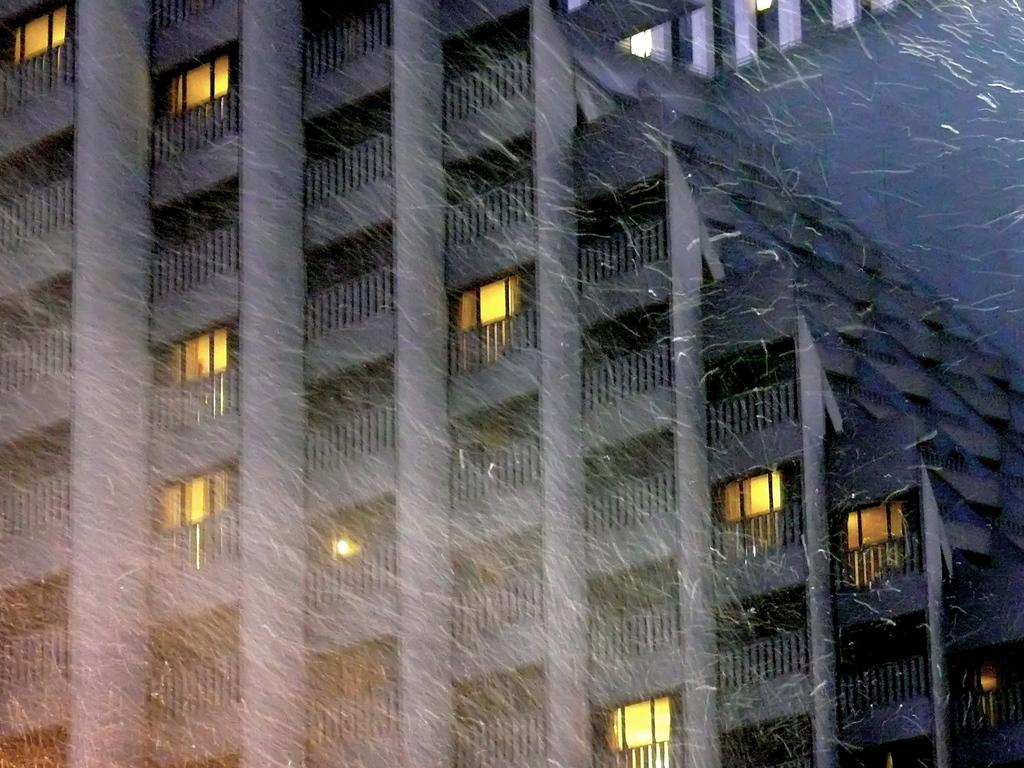What is the main structure in the image? There is a building in the image. What feature can be seen on the building? The building has windows. What weather condition is depicted in the image? There is snowfall in the image. What type of wax is being used to detail the building in the image? There is no wax or detailing work being done on the building in the image; it is a simple depiction of a building with snowfall. 